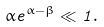<formula> <loc_0><loc_0><loc_500><loc_500>\alpha e ^ { \alpha - \beta } \ll 1 .</formula> 